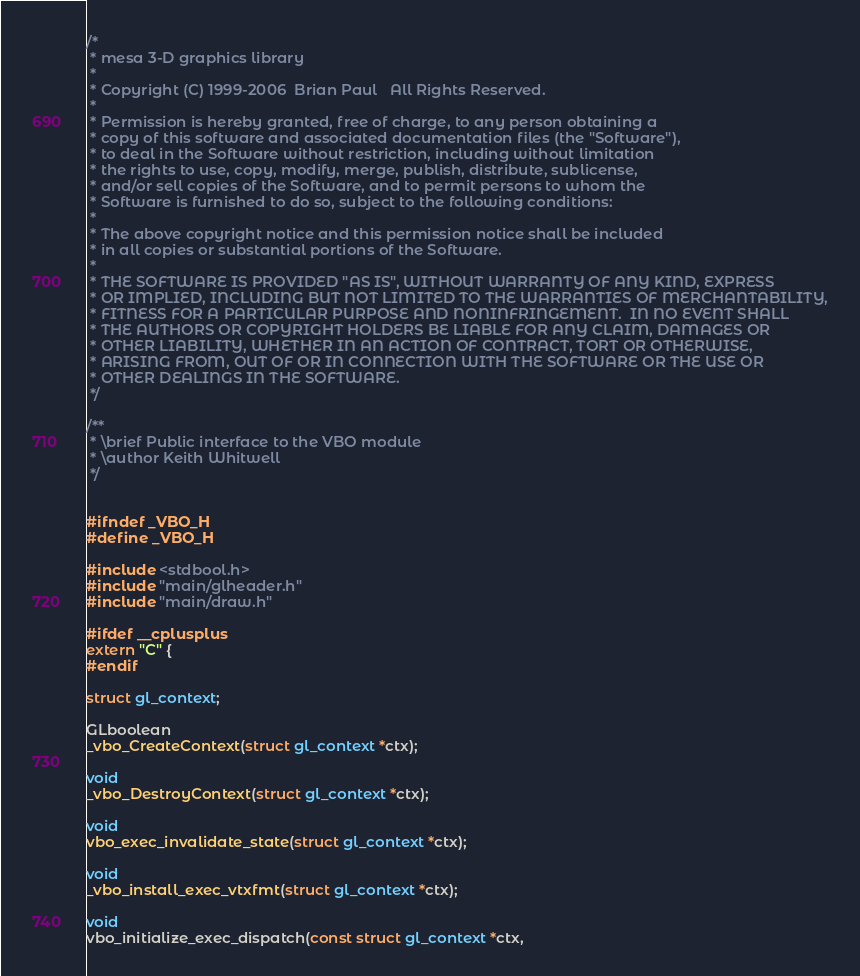<code> <loc_0><loc_0><loc_500><loc_500><_C_>/*
 * mesa 3-D graphics library
 *
 * Copyright (C) 1999-2006  Brian Paul   All Rights Reserved.
 *
 * Permission is hereby granted, free of charge, to any person obtaining a
 * copy of this software and associated documentation files (the "Software"),
 * to deal in the Software without restriction, including without limitation
 * the rights to use, copy, modify, merge, publish, distribute, sublicense,
 * and/or sell copies of the Software, and to permit persons to whom the
 * Software is furnished to do so, subject to the following conditions:
 *
 * The above copyright notice and this permission notice shall be included
 * in all copies or substantial portions of the Software.
 *
 * THE SOFTWARE IS PROVIDED "AS IS", WITHOUT WARRANTY OF ANY KIND, EXPRESS
 * OR IMPLIED, INCLUDING BUT NOT LIMITED TO THE WARRANTIES OF MERCHANTABILITY,
 * FITNESS FOR A PARTICULAR PURPOSE AND NONINFRINGEMENT.  IN NO EVENT SHALL
 * THE AUTHORS OR COPYRIGHT HOLDERS BE LIABLE FOR ANY CLAIM, DAMAGES OR
 * OTHER LIABILITY, WHETHER IN AN ACTION OF CONTRACT, TORT OR OTHERWISE,
 * ARISING FROM, OUT OF OR IN CONNECTION WITH THE SOFTWARE OR THE USE OR
 * OTHER DEALINGS IN THE SOFTWARE.
 */

/**
 * \brief Public interface to the VBO module
 * \author Keith Whitwell
 */


#ifndef _VBO_H
#define _VBO_H

#include <stdbool.h>
#include "main/glheader.h"
#include "main/draw.h"

#ifdef __cplusplus
extern "C" {
#endif

struct gl_context;

GLboolean
_vbo_CreateContext(struct gl_context *ctx);

void
_vbo_DestroyContext(struct gl_context *ctx);

void
vbo_exec_invalidate_state(struct gl_context *ctx);

void
_vbo_install_exec_vtxfmt(struct gl_context *ctx);

void
vbo_initialize_exec_dispatch(const struct gl_context *ctx,</code> 